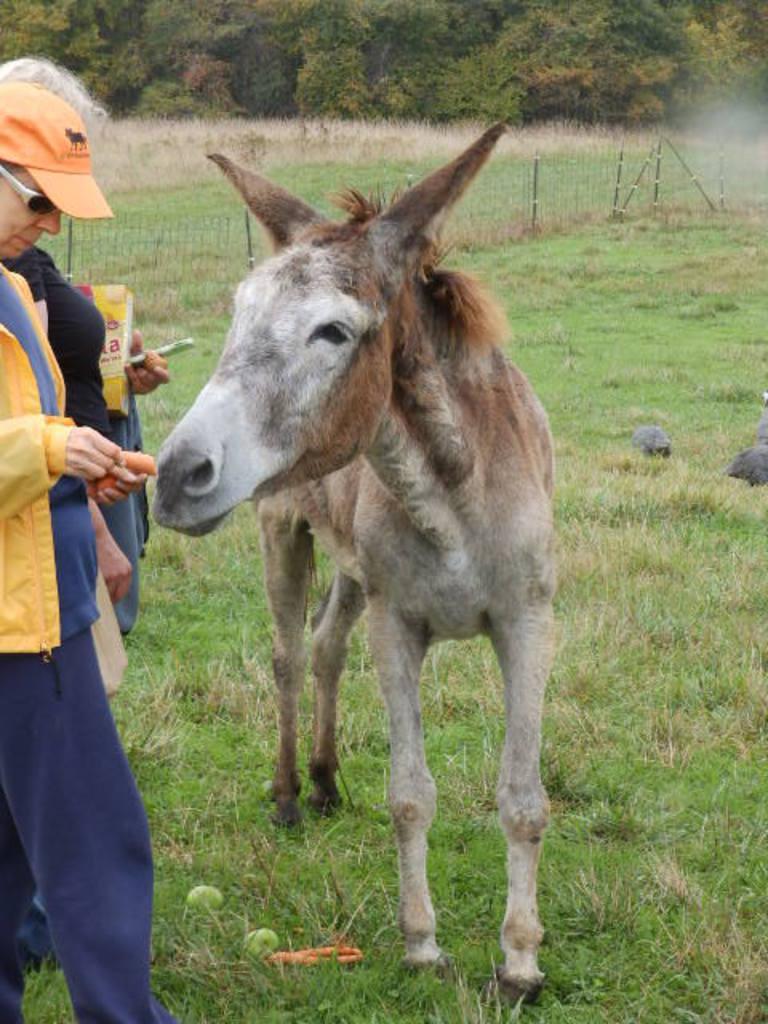How would you summarize this image in a sentence or two? In the picture there is a ground, we can see a donkey on the ground, beside the donkey there are people standing, there is a fence, there is grass on the ground, there are trees. 